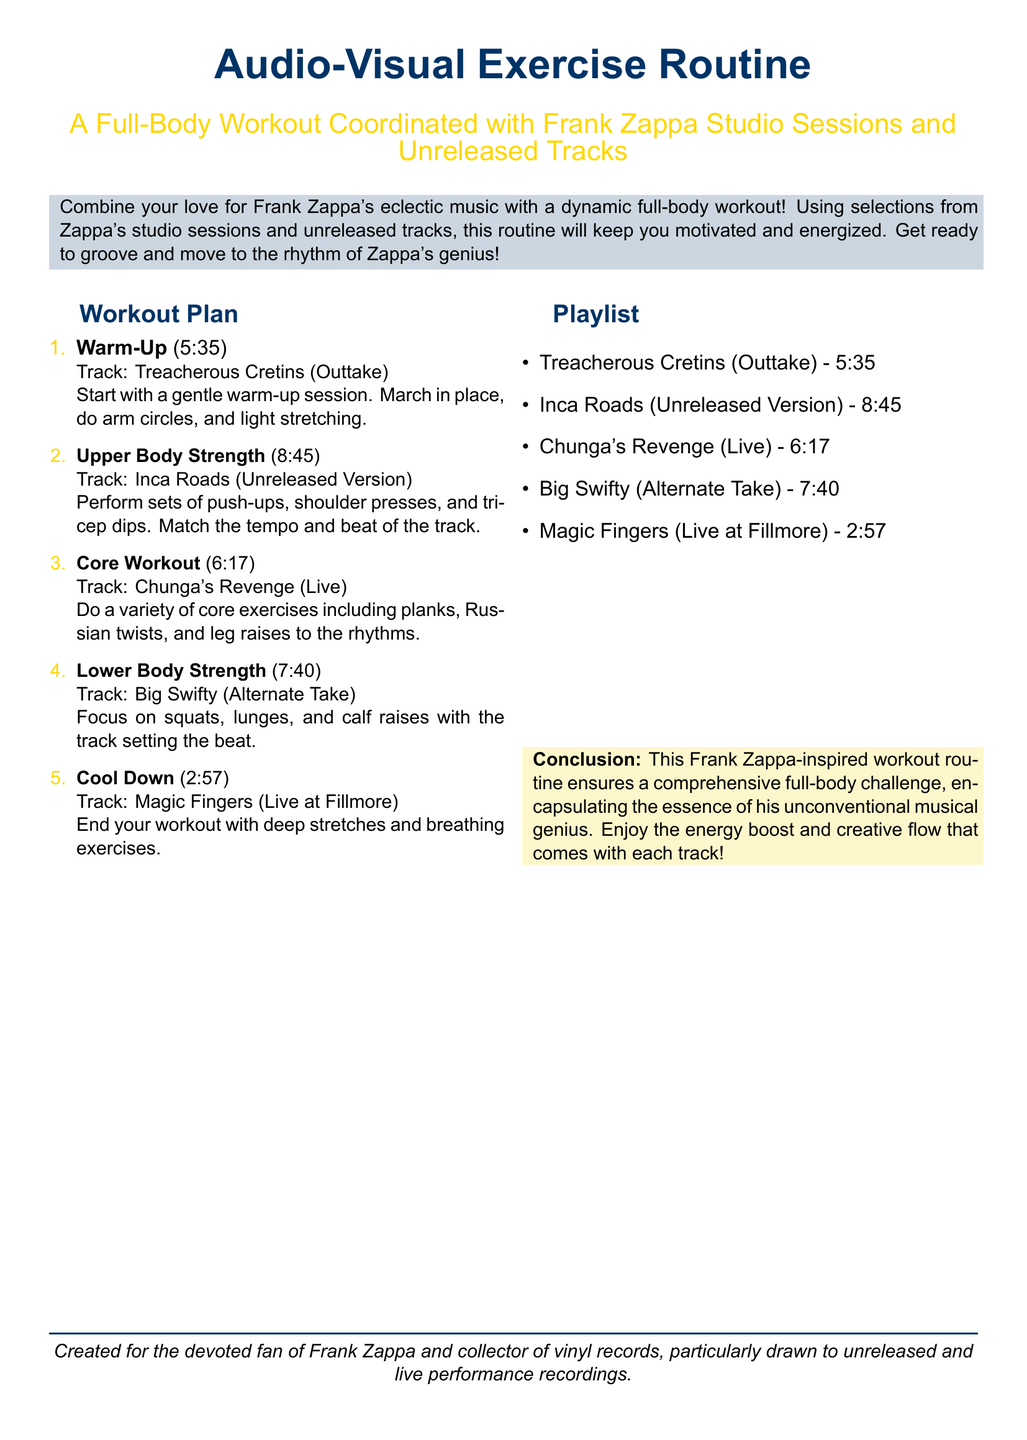What is the title of the workout plan? The title of the workout plan is presented at the beginning of the document as a prominent heading.
Answer: Audio-Visual Exercise Routine How long is the warm-up track? The duration of the warm-up track is specified in the exercise routine section.
Answer: 5:35 Which track is used for the upper body strength workout? The specific track listed for the upper body strength workout provides the necessary information.
Answer: Inca Roads (Unreleased Version) What type of exercises are included in the core workout? The types of exercises included are specifically defined under the core workout section.
Answer: Planks, Russian twists, leg raises What is the total duration of the lower body strength section? The total time for the lower body strength is directly mentioned in the document.
Answer: 7:40 Which track is specified for the cool down? The cool down track is clearly indicated in the list of exercises and associated music.
Answer: Magic Fingers (Live at Fillmore) How many tracks are listed in the playlist? The total number of tracks mentioned can be counted from the playlist section.
Answer: 5 What color is used for the workout plan heading? The color of the workout plan heading is defined in the document.
Answer: Zappablue What theme does the workout plan incorporate? The overarching theme of the workout routine is highlighted in the introductory description.
Answer: Frank Zappa's music 